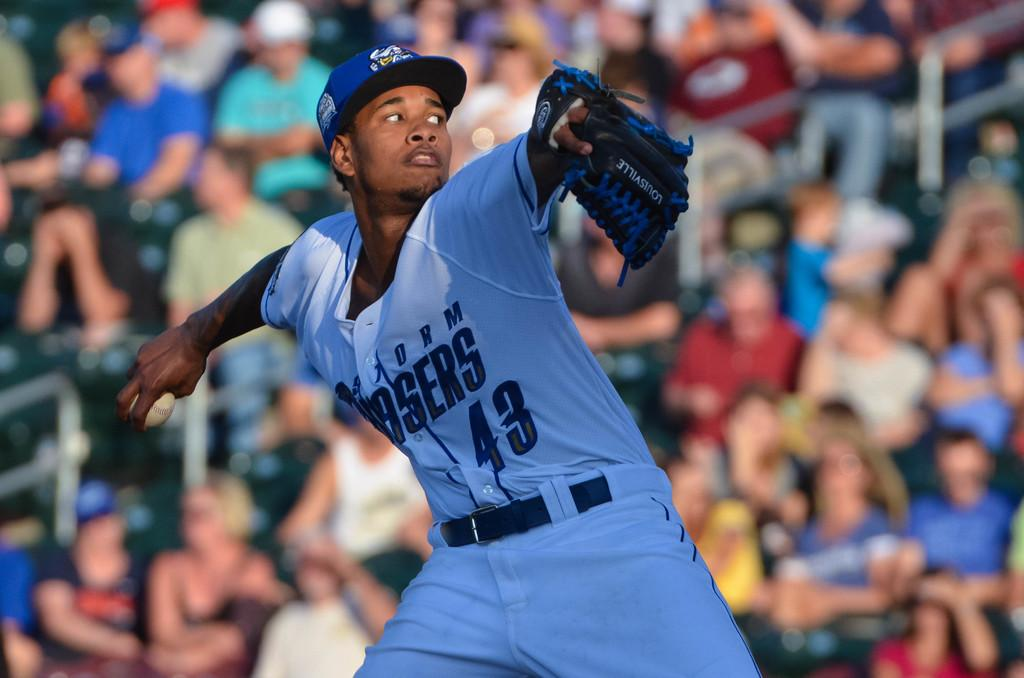<image>
Describe the image concisely. Number 43 is about to pitch the baseball. 